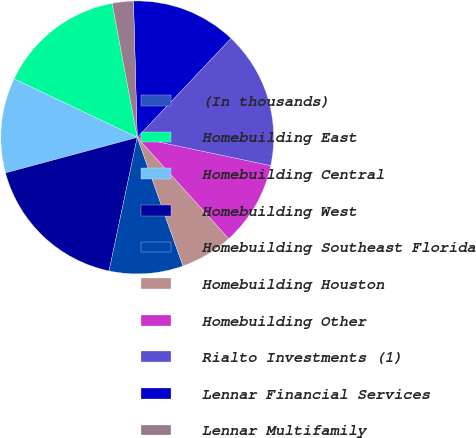Convert chart to OTSL. <chart><loc_0><loc_0><loc_500><loc_500><pie_chart><fcel>(In thousands)<fcel>Homebuilding East<fcel>Homebuilding Central<fcel>Homebuilding West<fcel>Homebuilding Southeast Florida<fcel>Homebuilding Houston<fcel>Homebuilding Other<fcel>Rialto Investments (1)<fcel>Lennar Financial Services<fcel>Lennar Multifamily<nl><fcel>0.0%<fcel>15.0%<fcel>11.25%<fcel>17.5%<fcel>8.75%<fcel>6.25%<fcel>10.0%<fcel>16.25%<fcel>12.5%<fcel>2.5%<nl></chart> 